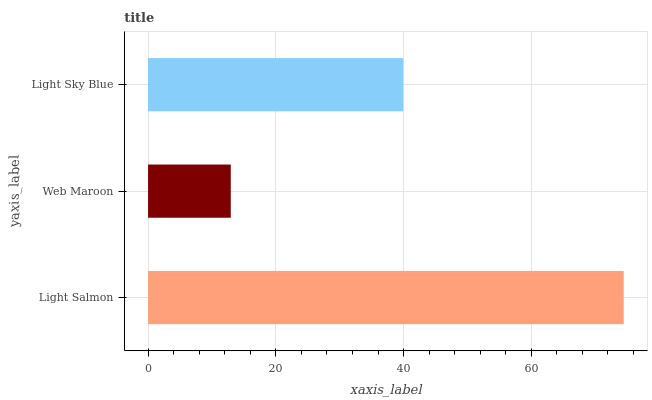Is Web Maroon the minimum?
Answer yes or no. Yes. Is Light Salmon the maximum?
Answer yes or no. Yes. Is Light Sky Blue the minimum?
Answer yes or no. No. Is Light Sky Blue the maximum?
Answer yes or no. No. Is Light Sky Blue greater than Web Maroon?
Answer yes or no. Yes. Is Web Maroon less than Light Sky Blue?
Answer yes or no. Yes. Is Web Maroon greater than Light Sky Blue?
Answer yes or no. No. Is Light Sky Blue less than Web Maroon?
Answer yes or no. No. Is Light Sky Blue the high median?
Answer yes or no. Yes. Is Light Sky Blue the low median?
Answer yes or no. Yes. Is Light Salmon the high median?
Answer yes or no. No. Is Web Maroon the low median?
Answer yes or no. No. 